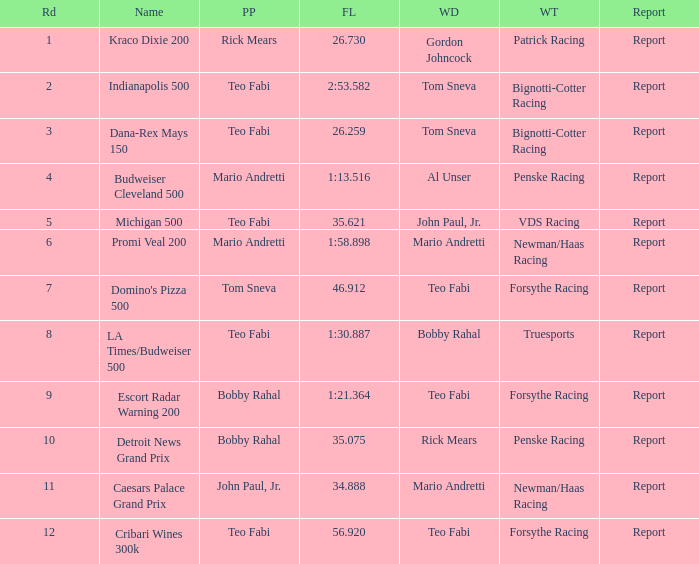Which Rd took place at the Indianapolis 500? 2.0. 